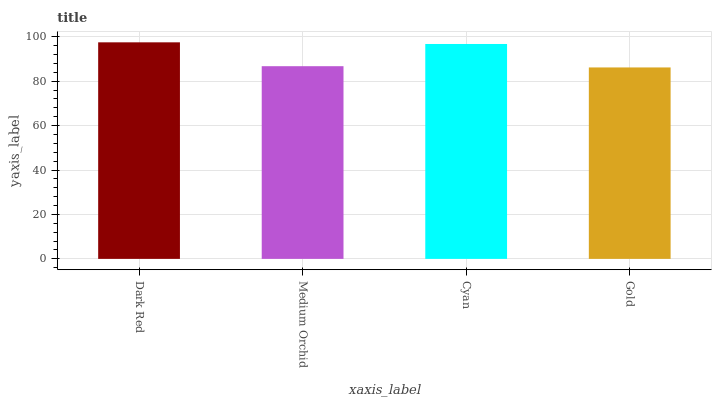Is Medium Orchid the minimum?
Answer yes or no. No. Is Medium Orchid the maximum?
Answer yes or no. No. Is Dark Red greater than Medium Orchid?
Answer yes or no. Yes. Is Medium Orchid less than Dark Red?
Answer yes or no. Yes. Is Medium Orchid greater than Dark Red?
Answer yes or no. No. Is Dark Red less than Medium Orchid?
Answer yes or no. No. Is Cyan the high median?
Answer yes or no. Yes. Is Medium Orchid the low median?
Answer yes or no. Yes. Is Medium Orchid the high median?
Answer yes or no. No. Is Gold the low median?
Answer yes or no. No. 